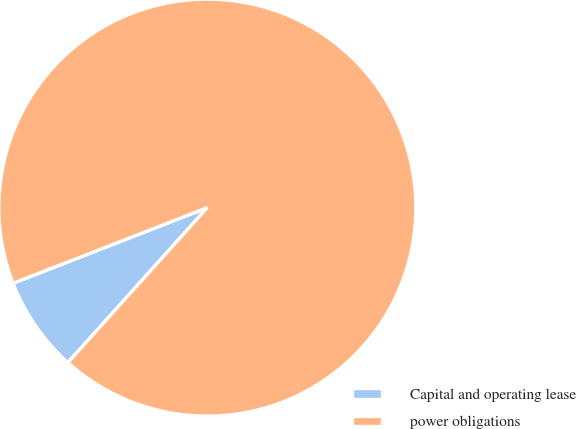Convert chart. <chart><loc_0><loc_0><loc_500><loc_500><pie_chart><fcel>Capital and operating lease<fcel>power obligations<nl><fcel>7.43%<fcel>92.57%<nl></chart> 